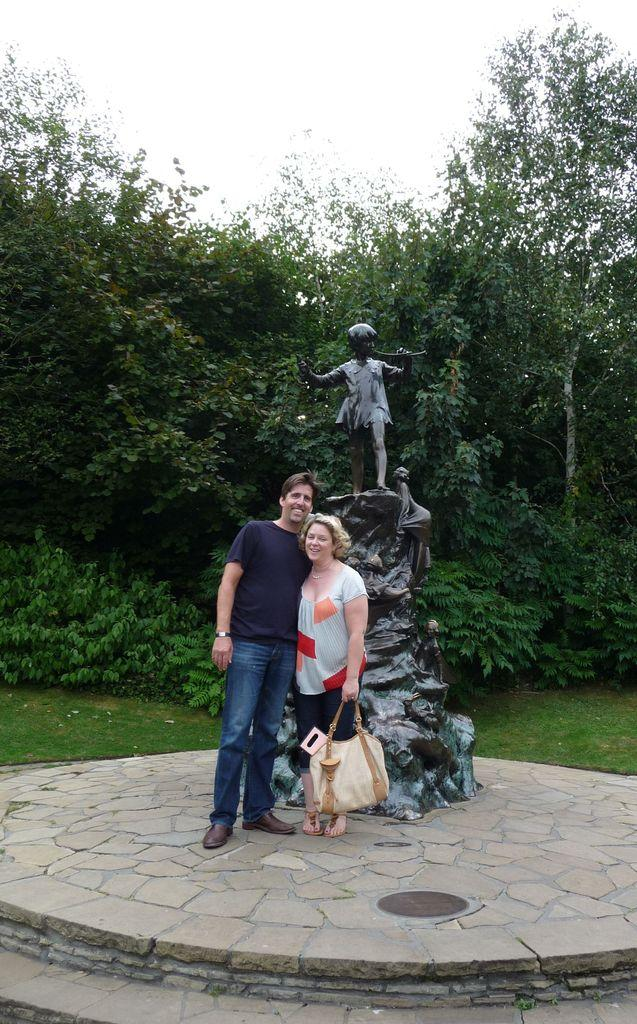How many people are present in the image? There are two people in the image, a woman and a man. What is the woman holding in the image? The woman is holding a bag. What can be seen in the background of the image? There is a statue, trees, and the sky visible in the background of the image. What type of throne is the man sitting on in the image? There is no throne present in the image; both the woman and the man are standing. 